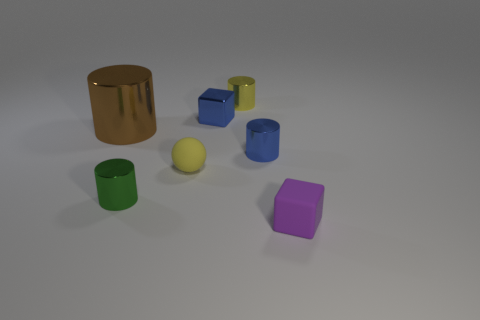Is the green object made of the same material as the tiny blue cylinder?
Your response must be concise. Yes. Is there any other thing that has the same material as the tiny green cylinder?
Offer a very short reply. Yes. Is the number of small objects on the left side of the yellow cylinder greater than the number of tiny green matte spheres?
Give a very brief answer. Yes. Does the small sphere have the same color as the shiny block?
Make the answer very short. No. How many small blue objects have the same shape as the tiny purple thing?
Offer a terse response. 1. What is the size of the blue cylinder that is the same material as the large brown thing?
Your answer should be very brief. Small. The cylinder that is both to the right of the blue cube and in front of the big shiny cylinder is what color?
Offer a terse response. Blue. What number of cubes are the same size as the yellow metallic object?
Provide a succinct answer. 2. There is a thing that is the same color as the small sphere; what is its size?
Make the answer very short. Small. How big is the cylinder that is in front of the big brown shiny cylinder and right of the green cylinder?
Keep it short and to the point. Small. 